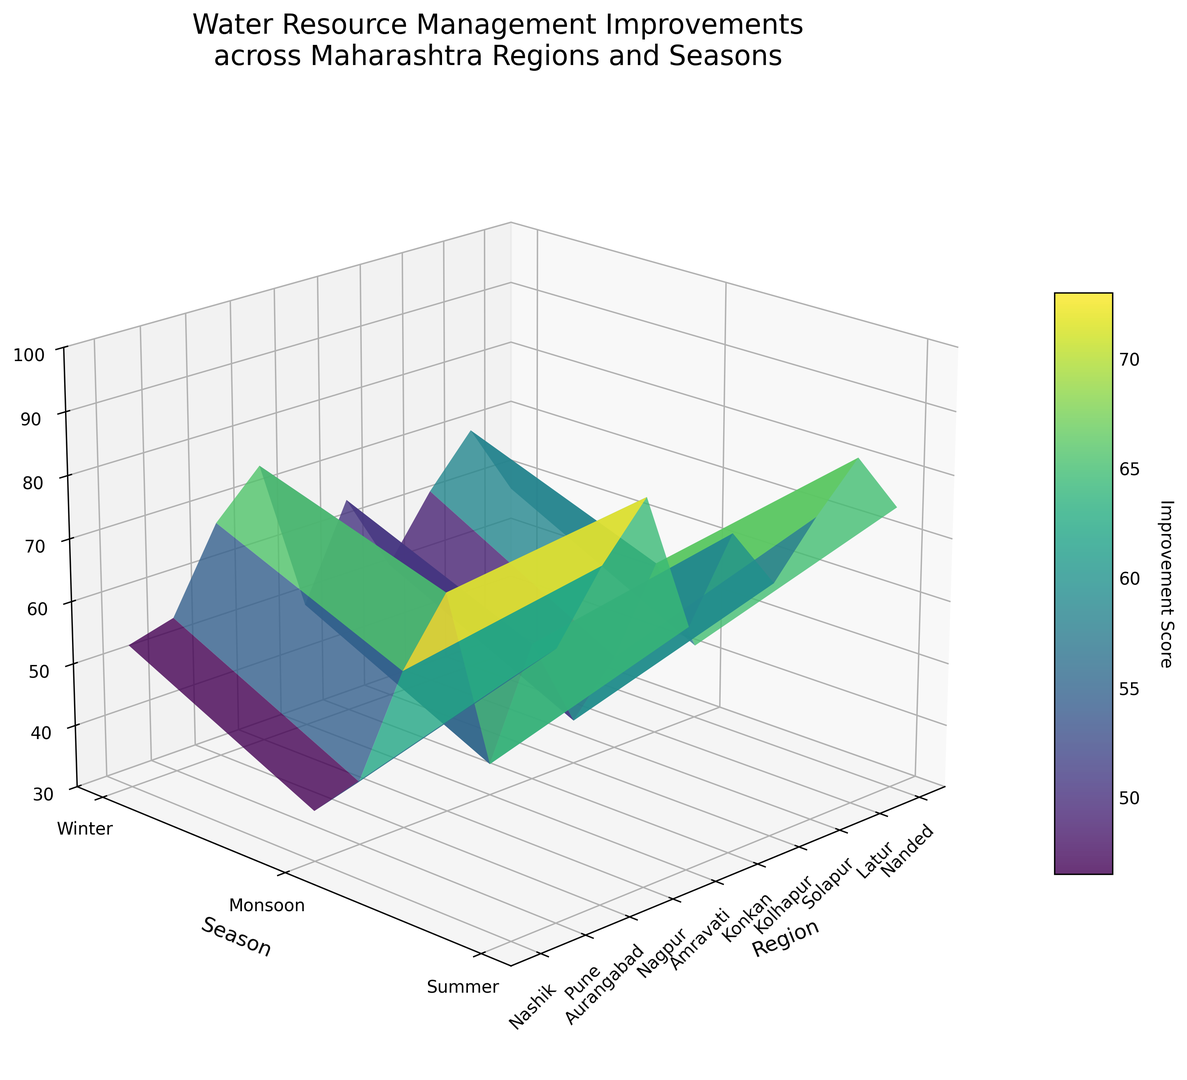How does the improvement score in Nashik differ between summer and winter? To find the difference in improvement scores between these two seasons in Nashik, look at the scores directly for both seasons. For summer, Nashik has 45, and for winter, it is 62. Therefore, the difference is 62 - 45.
Answer: 17 Which region shows the highest improvement score during the monsoon season? Look at the improvement scores for each region during the monsoon season. The highest value corresponds to the region with the highest improvement score. Konkan has the highest score of 90 during the monsoon season.
Answer: Konkan What is the average improvement score for Pune across all seasons? To find the average, sum the scores for all seasons in Pune and divide by the number of scores. The scores are 58 (Summer), 85 (Monsoon), and 70 (Winter). So, the average is (58 + 85 + 70) / 3.
Answer: 71 Comparing Nagpur and Kolhapur, which region had a higher improvement in the winter season? Look at the improvement scores for Nagpur and Kolhapur during the winter season. Nagpur has 65, while Kolhapur has 68. Kolhapur's score is higher.
Answer: Kolhapur How does the summer improvement score of Solapur compare to that of Amravati? Check the improvement scores for Solapur and Amravati during the summer. Solapur has a score of 42, and Amravati has 38. Therefore, Solapur's score is higher.
Answer: Solapur What is the overall trend in improvement scores across seasons in the Konkan region? Observe the improvement scores for Konkan across all three seasons. Summer (65), Monsoon (90), and Winter (75). The general trend shows a peak in the monsoon, with relatively high improvements in both summer and winter.
Answer: Peak in Monsoon Which region has the lowest improvement score during the summer, and what is it? Find the lowest score among all regions during the summer. Latur has the lowest improvement score of 35 in the summer.
Answer: Latur, 35 What is the improvement score range for the Aurangabad region across all seasons? To find the range, identify the maximum and minimum scores for Aurangabad across the seasons. The scores are 40 (Summer), 72 (Monsoon), and 55 (Winter). The range is 72 - 40.
Answer: 32 